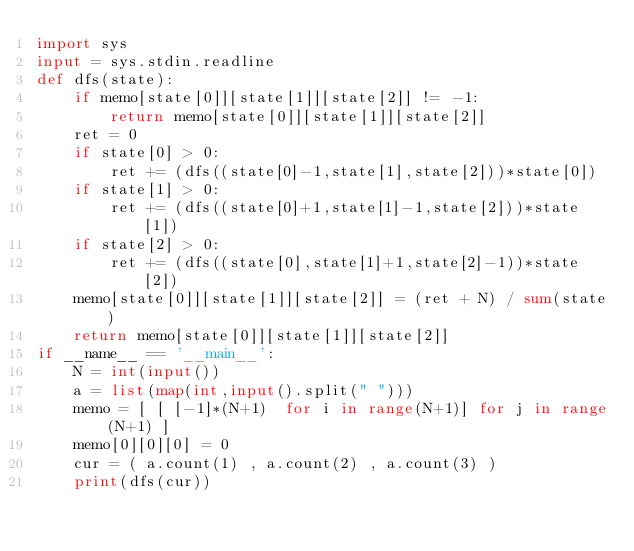Convert code to text. <code><loc_0><loc_0><loc_500><loc_500><_Python_>import sys 
input = sys.stdin.readline
def dfs(state):
    if memo[state[0]][state[1]][state[2]] != -1:
        return memo[state[0]][state[1]][state[2]]
    ret = 0
    if state[0] > 0:
        ret += (dfs((state[0]-1,state[1],state[2]))*state[0])
    if state[1] > 0:
        ret += (dfs((state[0]+1,state[1]-1,state[2]))*state[1])
    if state[2] > 0:
        ret += (dfs((state[0],state[1]+1,state[2]-1))*state[2])
    memo[state[0]][state[1]][state[2]] = (ret + N) / sum(state)
    return memo[state[0]][state[1]][state[2]]
if __name__ == '__main__':
    N = int(input())
    a = list(map(int,input().split(" ")))
    memo = [ [ [-1]*(N+1)  for i in range(N+1)] for j in range(N+1) ]
    memo[0][0][0] = 0
    cur = ( a.count(1) , a.count(2) , a.count(3) )
    print(dfs(cur))</code> 